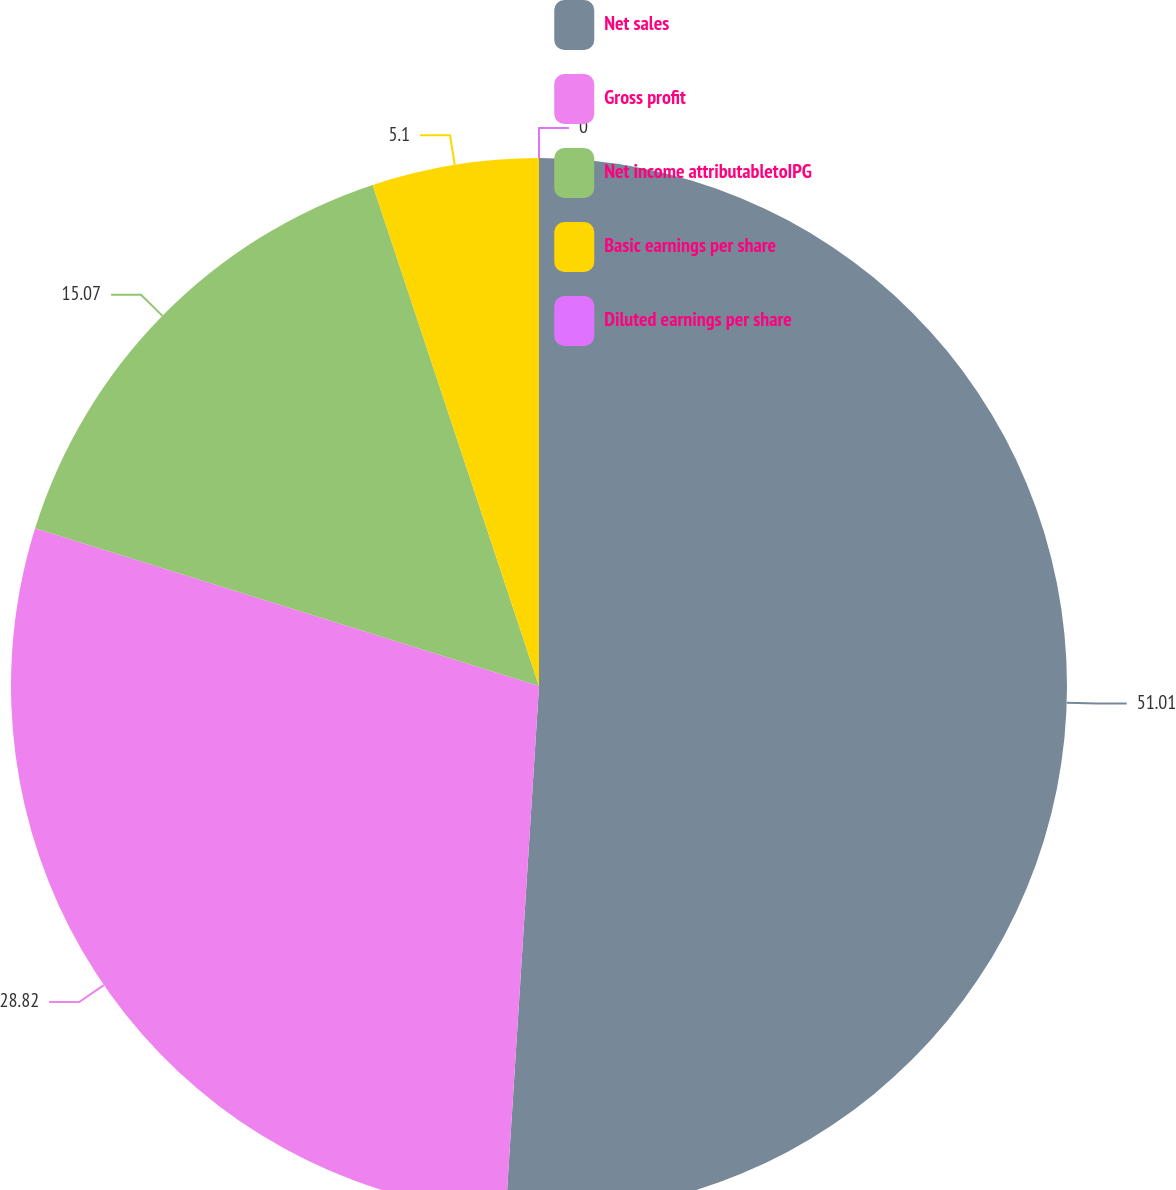Convert chart to OTSL. <chart><loc_0><loc_0><loc_500><loc_500><pie_chart><fcel>Net sales<fcel>Gross profit<fcel>Net income attributabletoIPG<fcel>Basic earnings per share<fcel>Diluted earnings per share<nl><fcel>51.0%<fcel>28.82%<fcel>15.07%<fcel>5.1%<fcel>0.0%<nl></chart> 